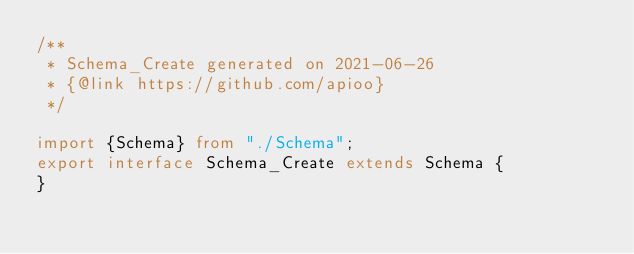Convert code to text. <code><loc_0><loc_0><loc_500><loc_500><_TypeScript_>/**
 * Schema_Create generated on 2021-06-26
 * {@link https://github.com/apioo}
 */

import {Schema} from "./Schema";
export interface Schema_Create extends Schema {
}
</code> 